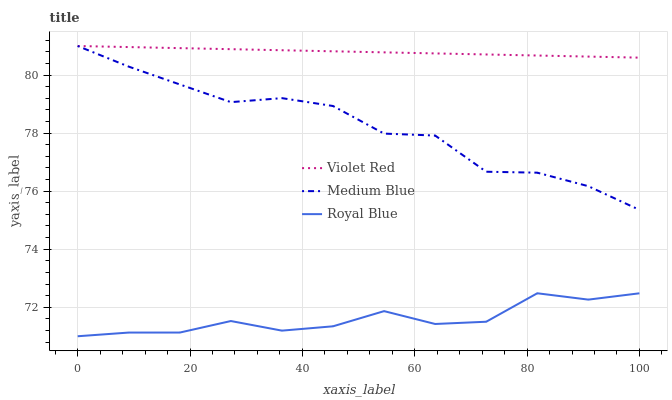Does Royal Blue have the minimum area under the curve?
Answer yes or no. Yes. Does Violet Red have the maximum area under the curve?
Answer yes or no. Yes. Does Medium Blue have the minimum area under the curve?
Answer yes or no. No. Does Medium Blue have the maximum area under the curve?
Answer yes or no. No. Is Violet Red the smoothest?
Answer yes or no. Yes. Is Royal Blue the roughest?
Answer yes or no. Yes. Is Medium Blue the smoothest?
Answer yes or no. No. Is Medium Blue the roughest?
Answer yes or no. No. Does Medium Blue have the lowest value?
Answer yes or no. No. Does Medium Blue have the highest value?
Answer yes or no. Yes. Is Royal Blue less than Medium Blue?
Answer yes or no. Yes. Is Medium Blue greater than Royal Blue?
Answer yes or no. Yes. Does Royal Blue intersect Medium Blue?
Answer yes or no. No. 